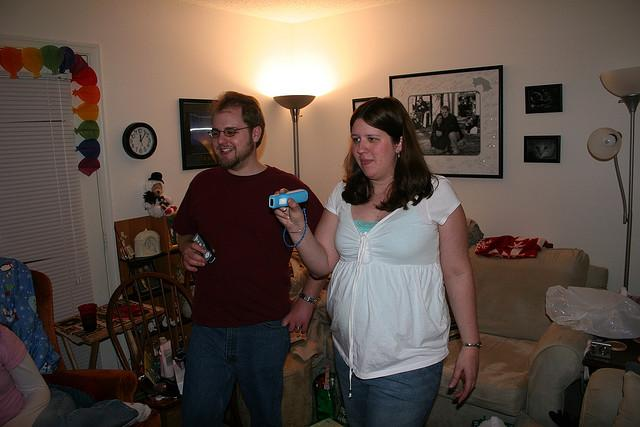What session of the day is it? Please explain your reasoning. midnight. The session takes place at midnight because the clock on the wall says it is close to 12:00. 